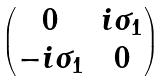<formula> <loc_0><loc_0><loc_500><loc_500>\begin{pmatrix} 0 & i \sigma _ { 1 } \\ - i \sigma _ { 1 } & 0 \end{pmatrix}</formula> 